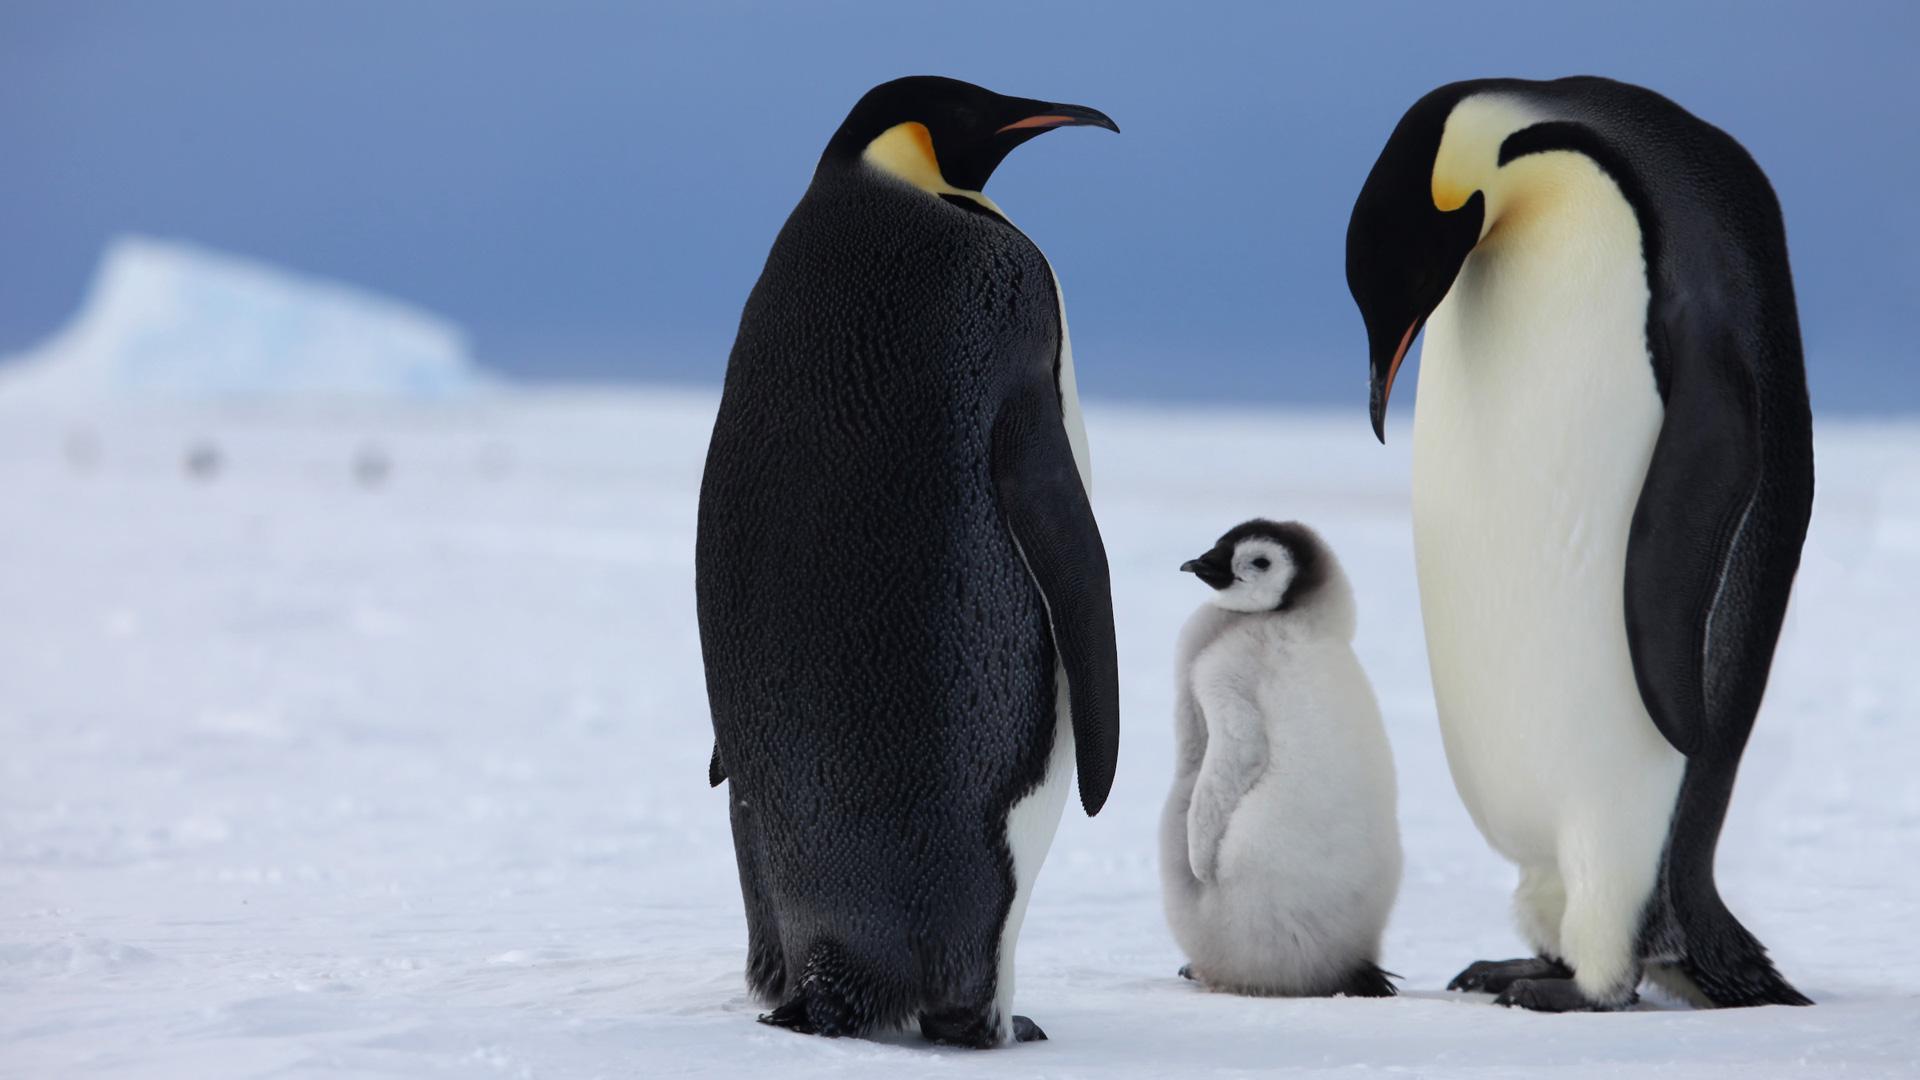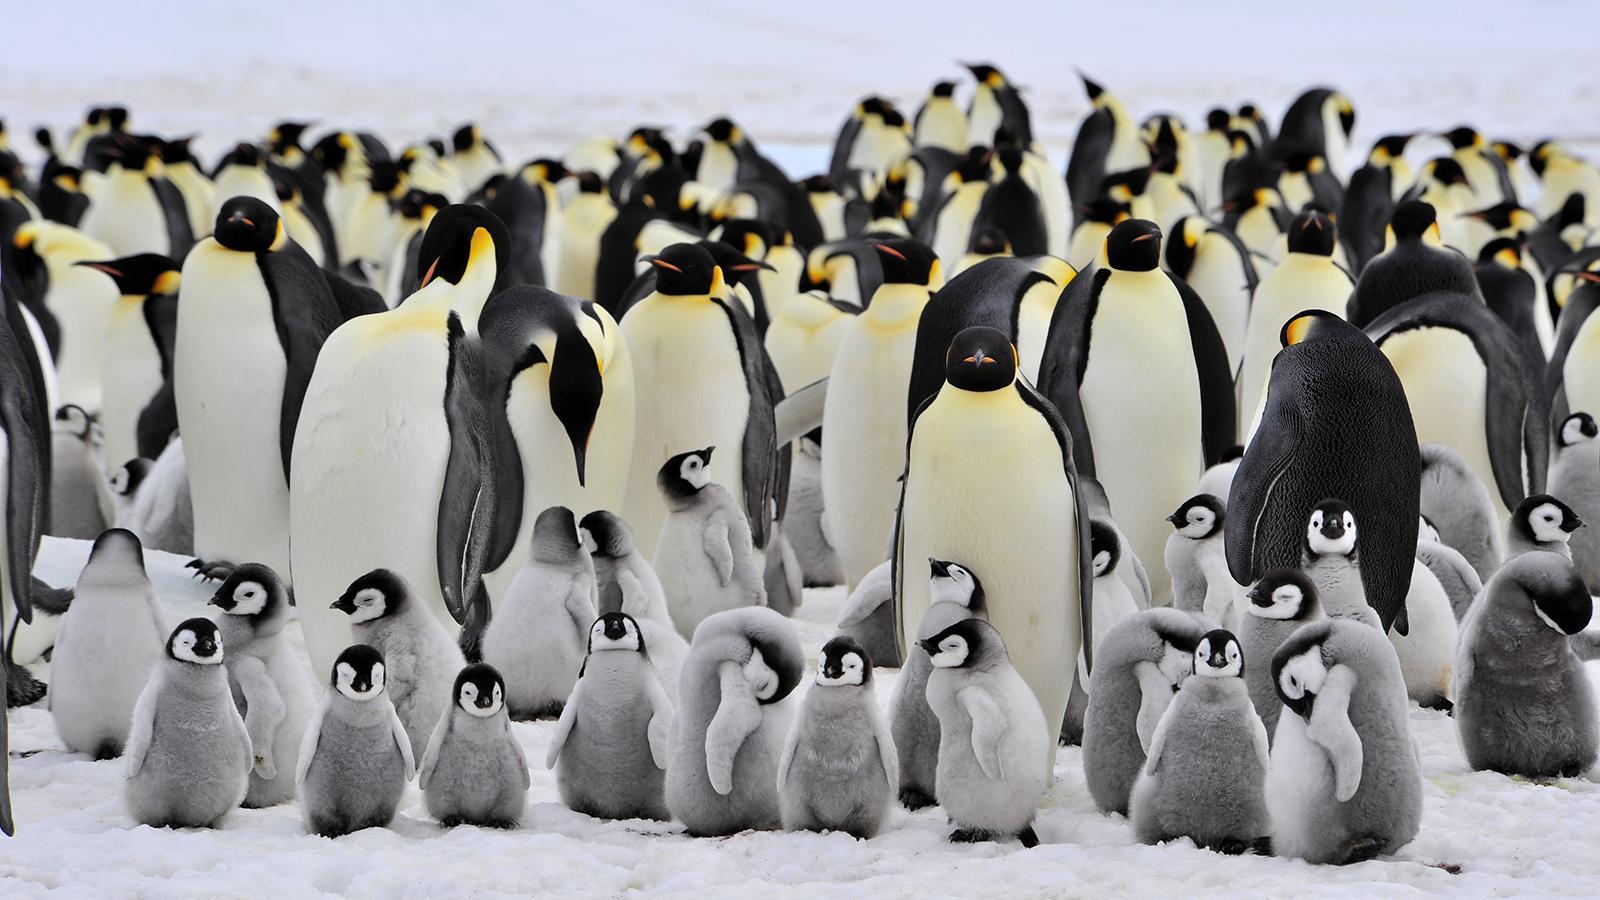The first image is the image on the left, the second image is the image on the right. For the images shown, is this caption "In the left image, there are two adult penguins and one baby penguin" true? Answer yes or no. Yes. The first image is the image on the left, the second image is the image on the right. Given the left and right images, does the statement "One image shows only one penguin family, with parents flanking a baby." hold true? Answer yes or no. Yes. 